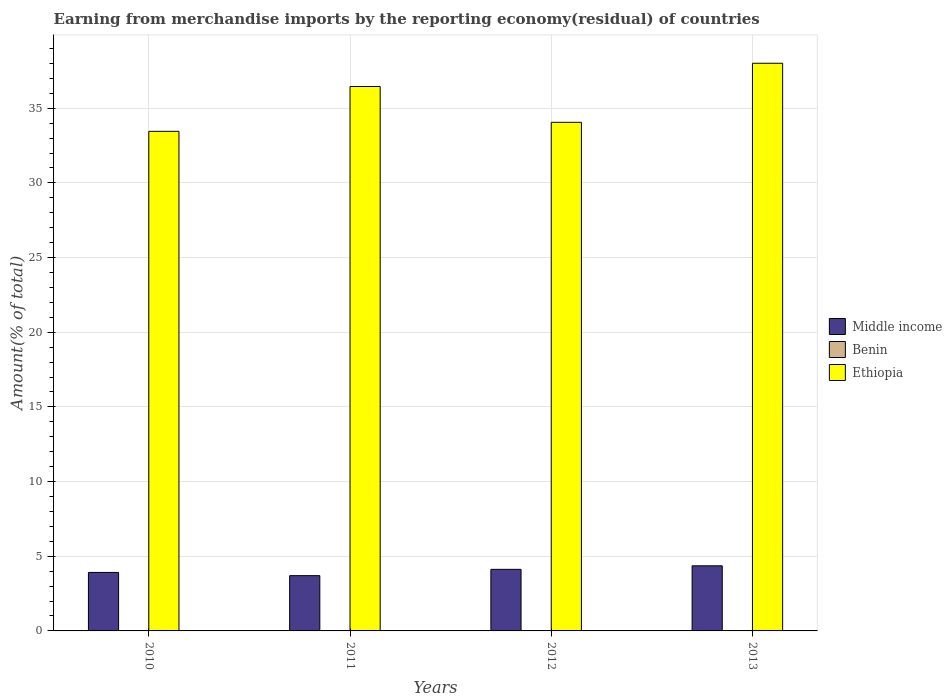Are the number of bars per tick equal to the number of legend labels?
Give a very brief answer. Yes. How many bars are there on the 3rd tick from the right?
Provide a succinct answer. 3. What is the label of the 2nd group of bars from the left?
Provide a short and direct response. 2011. In how many cases, is the number of bars for a given year not equal to the number of legend labels?
Provide a succinct answer. 0. What is the percentage of amount earned from merchandise imports in Middle income in 2012?
Offer a terse response. 4.12. Across all years, what is the maximum percentage of amount earned from merchandise imports in Middle income?
Ensure brevity in your answer.  4.36. Across all years, what is the minimum percentage of amount earned from merchandise imports in Middle income?
Offer a very short reply. 3.7. In which year was the percentage of amount earned from merchandise imports in Ethiopia maximum?
Your answer should be compact. 2013. What is the total percentage of amount earned from merchandise imports in Benin in the graph?
Offer a terse response. 0.06. What is the difference between the percentage of amount earned from merchandise imports in Ethiopia in 2011 and that in 2013?
Ensure brevity in your answer.  -1.56. What is the difference between the percentage of amount earned from merchandise imports in Ethiopia in 2011 and the percentage of amount earned from merchandise imports in Benin in 2013?
Ensure brevity in your answer.  36.44. What is the average percentage of amount earned from merchandise imports in Middle income per year?
Give a very brief answer. 4.03. In the year 2011, what is the difference between the percentage of amount earned from merchandise imports in Benin and percentage of amount earned from merchandise imports in Middle income?
Your answer should be compact. -3.69. What is the ratio of the percentage of amount earned from merchandise imports in Middle income in 2011 to that in 2012?
Provide a short and direct response. 0.9. What is the difference between the highest and the second highest percentage of amount earned from merchandise imports in Benin?
Provide a succinct answer. 0. What is the difference between the highest and the lowest percentage of amount earned from merchandise imports in Middle income?
Give a very brief answer. 0.66. Is the sum of the percentage of amount earned from merchandise imports in Middle income in 2010 and 2012 greater than the maximum percentage of amount earned from merchandise imports in Ethiopia across all years?
Give a very brief answer. No. What does the 1st bar from the left in 2013 represents?
Provide a succinct answer. Middle income. What does the 1st bar from the right in 2013 represents?
Give a very brief answer. Ethiopia. How many bars are there?
Provide a succinct answer. 12. How many years are there in the graph?
Provide a short and direct response. 4. What is the difference between two consecutive major ticks on the Y-axis?
Provide a short and direct response. 5. Does the graph contain any zero values?
Your response must be concise. No. Does the graph contain grids?
Offer a very short reply. Yes. How many legend labels are there?
Give a very brief answer. 3. What is the title of the graph?
Provide a short and direct response. Earning from merchandise imports by the reporting economy(residual) of countries. What is the label or title of the X-axis?
Your answer should be very brief. Years. What is the label or title of the Y-axis?
Make the answer very short. Amount(% of total). What is the Amount(% of total) in Middle income in 2010?
Offer a terse response. 3.92. What is the Amount(% of total) in Benin in 2010?
Your response must be concise. 0.01. What is the Amount(% of total) of Ethiopia in 2010?
Offer a very short reply. 33.45. What is the Amount(% of total) of Middle income in 2011?
Ensure brevity in your answer.  3.7. What is the Amount(% of total) in Benin in 2011?
Your answer should be compact. 0.01. What is the Amount(% of total) in Ethiopia in 2011?
Your answer should be very brief. 36.45. What is the Amount(% of total) in Middle income in 2012?
Make the answer very short. 4.12. What is the Amount(% of total) in Benin in 2012?
Your response must be concise. 0.02. What is the Amount(% of total) of Ethiopia in 2012?
Keep it short and to the point. 34.05. What is the Amount(% of total) in Middle income in 2013?
Give a very brief answer. 4.36. What is the Amount(% of total) in Benin in 2013?
Provide a short and direct response. 0.02. What is the Amount(% of total) in Ethiopia in 2013?
Offer a terse response. 38.01. Across all years, what is the maximum Amount(% of total) in Middle income?
Keep it short and to the point. 4.36. Across all years, what is the maximum Amount(% of total) of Benin?
Offer a very short reply. 0.02. Across all years, what is the maximum Amount(% of total) of Ethiopia?
Your answer should be compact. 38.01. Across all years, what is the minimum Amount(% of total) in Middle income?
Offer a very short reply. 3.7. Across all years, what is the minimum Amount(% of total) of Benin?
Ensure brevity in your answer.  0.01. Across all years, what is the minimum Amount(% of total) of Ethiopia?
Give a very brief answer. 33.45. What is the total Amount(% of total) in Middle income in the graph?
Ensure brevity in your answer.  16.1. What is the total Amount(% of total) in Benin in the graph?
Ensure brevity in your answer.  0.06. What is the total Amount(% of total) in Ethiopia in the graph?
Provide a succinct answer. 141.97. What is the difference between the Amount(% of total) of Middle income in 2010 and that in 2011?
Offer a very short reply. 0.22. What is the difference between the Amount(% of total) in Benin in 2010 and that in 2011?
Make the answer very short. 0. What is the difference between the Amount(% of total) of Ethiopia in 2010 and that in 2011?
Provide a succinct answer. -3. What is the difference between the Amount(% of total) of Middle income in 2010 and that in 2012?
Provide a short and direct response. -0.21. What is the difference between the Amount(% of total) in Benin in 2010 and that in 2012?
Your response must be concise. -0. What is the difference between the Amount(% of total) in Ethiopia in 2010 and that in 2012?
Your answer should be compact. -0.6. What is the difference between the Amount(% of total) of Middle income in 2010 and that in 2013?
Your response must be concise. -0.44. What is the difference between the Amount(% of total) in Benin in 2010 and that in 2013?
Provide a succinct answer. -0. What is the difference between the Amount(% of total) in Ethiopia in 2010 and that in 2013?
Provide a short and direct response. -4.56. What is the difference between the Amount(% of total) in Middle income in 2011 and that in 2012?
Make the answer very short. -0.42. What is the difference between the Amount(% of total) of Benin in 2011 and that in 2012?
Your answer should be very brief. -0.01. What is the difference between the Amount(% of total) of Ethiopia in 2011 and that in 2012?
Provide a succinct answer. 2.4. What is the difference between the Amount(% of total) of Middle income in 2011 and that in 2013?
Your answer should be compact. -0.66. What is the difference between the Amount(% of total) in Benin in 2011 and that in 2013?
Provide a short and direct response. -0. What is the difference between the Amount(% of total) in Ethiopia in 2011 and that in 2013?
Your answer should be compact. -1.56. What is the difference between the Amount(% of total) in Middle income in 2012 and that in 2013?
Your answer should be compact. -0.24. What is the difference between the Amount(% of total) in Benin in 2012 and that in 2013?
Your answer should be compact. 0. What is the difference between the Amount(% of total) in Ethiopia in 2012 and that in 2013?
Offer a terse response. -3.95. What is the difference between the Amount(% of total) of Middle income in 2010 and the Amount(% of total) of Benin in 2011?
Ensure brevity in your answer.  3.91. What is the difference between the Amount(% of total) in Middle income in 2010 and the Amount(% of total) in Ethiopia in 2011?
Your response must be concise. -32.54. What is the difference between the Amount(% of total) of Benin in 2010 and the Amount(% of total) of Ethiopia in 2011?
Make the answer very short. -36.44. What is the difference between the Amount(% of total) of Middle income in 2010 and the Amount(% of total) of Benin in 2012?
Make the answer very short. 3.9. What is the difference between the Amount(% of total) in Middle income in 2010 and the Amount(% of total) in Ethiopia in 2012?
Offer a terse response. -30.14. What is the difference between the Amount(% of total) of Benin in 2010 and the Amount(% of total) of Ethiopia in 2012?
Keep it short and to the point. -34.04. What is the difference between the Amount(% of total) in Middle income in 2010 and the Amount(% of total) in Benin in 2013?
Your answer should be compact. 3.9. What is the difference between the Amount(% of total) in Middle income in 2010 and the Amount(% of total) in Ethiopia in 2013?
Offer a very short reply. -34.09. What is the difference between the Amount(% of total) of Benin in 2010 and the Amount(% of total) of Ethiopia in 2013?
Offer a very short reply. -38. What is the difference between the Amount(% of total) in Middle income in 2011 and the Amount(% of total) in Benin in 2012?
Your answer should be compact. 3.68. What is the difference between the Amount(% of total) in Middle income in 2011 and the Amount(% of total) in Ethiopia in 2012?
Offer a terse response. -30.35. What is the difference between the Amount(% of total) in Benin in 2011 and the Amount(% of total) in Ethiopia in 2012?
Offer a very short reply. -34.04. What is the difference between the Amount(% of total) of Middle income in 2011 and the Amount(% of total) of Benin in 2013?
Your answer should be compact. 3.69. What is the difference between the Amount(% of total) of Middle income in 2011 and the Amount(% of total) of Ethiopia in 2013?
Your response must be concise. -34.31. What is the difference between the Amount(% of total) of Benin in 2011 and the Amount(% of total) of Ethiopia in 2013?
Make the answer very short. -38. What is the difference between the Amount(% of total) of Middle income in 2012 and the Amount(% of total) of Benin in 2013?
Give a very brief answer. 4.11. What is the difference between the Amount(% of total) in Middle income in 2012 and the Amount(% of total) in Ethiopia in 2013?
Keep it short and to the point. -33.89. What is the difference between the Amount(% of total) in Benin in 2012 and the Amount(% of total) in Ethiopia in 2013?
Make the answer very short. -37.99. What is the average Amount(% of total) of Middle income per year?
Provide a succinct answer. 4.03. What is the average Amount(% of total) of Benin per year?
Ensure brevity in your answer.  0.01. What is the average Amount(% of total) in Ethiopia per year?
Offer a terse response. 35.49. In the year 2010, what is the difference between the Amount(% of total) in Middle income and Amount(% of total) in Benin?
Ensure brevity in your answer.  3.9. In the year 2010, what is the difference between the Amount(% of total) in Middle income and Amount(% of total) in Ethiopia?
Keep it short and to the point. -29.53. In the year 2010, what is the difference between the Amount(% of total) of Benin and Amount(% of total) of Ethiopia?
Your answer should be very brief. -33.44. In the year 2011, what is the difference between the Amount(% of total) of Middle income and Amount(% of total) of Benin?
Keep it short and to the point. 3.69. In the year 2011, what is the difference between the Amount(% of total) in Middle income and Amount(% of total) in Ethiopia?
Offer a terse response. -32.75. In the year 2011, what is the difference between the Amount(% of total) of Benin and Amount(% of total) of Ethiopia?
Offer a very short reply. -36.44. In the year 2012, what is the difference between the Amount(% of total) in Middle income and Amount(% of total) in Benin?
Provide a short and direct response. 4.11. In the year 2012, what is the difference between the Amount(% of total) of Middle income and Amount(% of total) of Ethiopia?
Keep it short and to the point. -29.93. In the year 2012, what is the difference between the Amount(% of total) in Benin and Amount(% of total) in Ethiopia?
Offer a terse response. -34.04. In the year 2013, what is the difference between the Amount(% of total) of Middle income and Amount(% of total) of Benin?
Provide a succinct answer. 4.34. In the year 2013, what is the difference between the Amount(% of total) in Middle income and Amount(% of total) in Ethiopia?
Your answer should be very brief. -33.65. In the year 2013, what is the difference between the Amount(% of total) of Benin and Amount(% of total) of Ethiopia?
Your answer should be compact. -37.99. What is the ratio of the Amount(% of total) in Middle income in 2010 to that in 2011?
Offer a very short reply. 1.06. What is the ratio of the Amount(% of total) in Benin in 2010 to that in 2011?
Provide a succinct answer. 1.3. What is the ratio of the Amount(% of total) in Ethiopia in 2010 to that in 2011?
Ensure brevity in your answer.  0.92. What is the ratio of the Amount(% of total) of Middle income in 2010 to that in 2012?
Offer a very short reply. 0.95. What is the ratio of the Amount(% of total) in Benin in 2010 to that in 2012?
Provide a succinct answer. 0.83. What is the ratio of the Amount(% of total) of Ethiopia in 2010 to that in 2012?
Your answer should be compact. 0.98. What is the ratio of the Amount(% of total) in Middle income in 2010 to that in 2013?
Offer a very short reply. 0.9. What is the ratio of the Amount(% of total) of Benin in 2010 to that in 2013?
Provide a short and direct response. 0.93. What is the ratio of the Amount(% of total) in Ethiopia in 2010 to that in 2013?
Your response must be concise. 0.88. What is the ratio of the Amount(% of total) of Middle income in 2011 to that in 2012?
Provide a succinct answer. 0.9. What is the ratio of the Amount(% of total) of Benin in 2011 to that in 2012?
Offer a very short reply. 0.64. What is the ratio of the Amount(% of total) in Ethiopia in 2011 to that in 2012?
Offer a very short reply. 1.07. What is the ratio of the Amount(% of total) in Middle income in 2011 to that in 2013?
Ensure brevity in your answer.  0.85. What is the ratio of the Amount(% of total) of Benin in 2011 to that in 2013?
Ensure brevity in your answer.  0.72. What is the ratio of the Amount(% of total) in Middle income in 2012 to that in 2013?
Your response must be concise. 0.95. What is the ratio of the Amount(% of total) in Benin in 2012 to that in 2013?
Your response must be concise. 1.13. What is the ratio of the Amount(% of total) of Ethiopia in 2012 to that in 2013?
Make the answer very short. 0.9. What is the difference between the highest and the second highest Amount(% of total) of Middle income?
Provide a short and direct response. 0.24. What is the difference between the highest and the second highest Amount(% of total) of Benin?
Your answer should be compact. 0. What is the difference between the highest and the second highest Amount(% of total) in Ethiopia?
Give a very brief answer. 1.56. What is the difference between the highest and the lowest Amount(% of total) of Middle income?
Offer a very short reply. 0.66. What is the difference between the highest and the lowest Amount(% of total) in Benin?
Your answer should be compact. 0.01. What is the difference between the highest and the lowest Amount(% of total) of Ethiopia?
Offer a terse response. 4.56. 